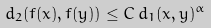<formula> <loc_0><loc_0><loc_500><loc_500>d _ { 2 } ( f ( x ) , f ( y ) ) \leq C \, d _ { 1 } ( x , y ) ^ { \alpha }</formula> 